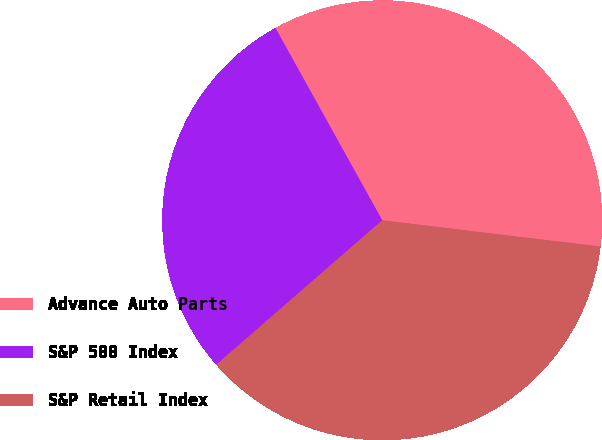Convert chart to OTSL. <chart><loc_0><loc_0><loc_500><loc_500><pie_chart><fcel>Advance Auto Parts<fcel>S&P 500 Index<fcel>S&P Retail Index<nl><fcel>34.97%<fcel>28.33%<fcel>36.7%<nl></chart> 